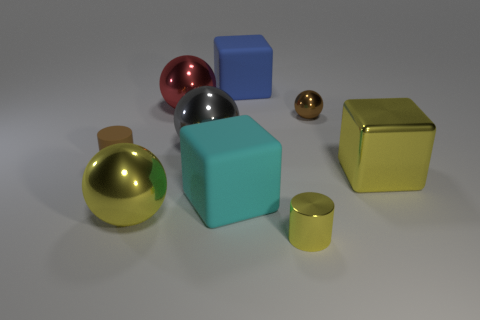Add 1 big green spheres. How many objects exist? 10 Subtract all cylinders. How many objects are left? 7 Add 9 small yellow metallic cylinders. How many small yellow metallic cylinders are left? 10 Add 4 rubber cylinders. How many rubber cylinders exist? 5 Subtract 0 purple spheres. How many objects are left? 9 Subtract all gray shiny cubes. Subtract all yellow things. How many objects are left? 6 